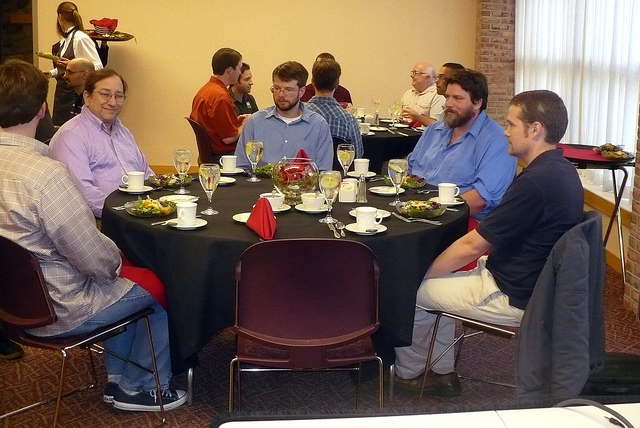How many people are in the image? The image depicts a gathering with four individuals sitting around a dining table, seemingly engaged in conversation and enjoying a meal together. 